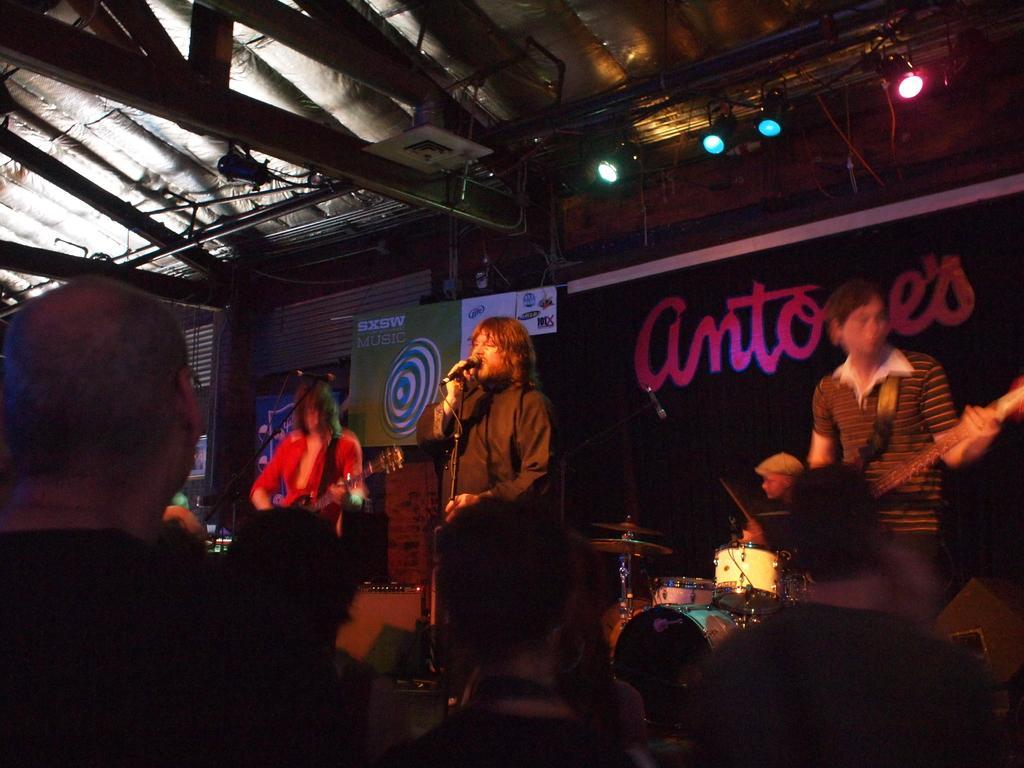Can you describe this image briefly? In this image I can see number of people are standing where two of them are holding guitars and one is holding a mic. In the background I can see a person is sitting next to a drum set. 